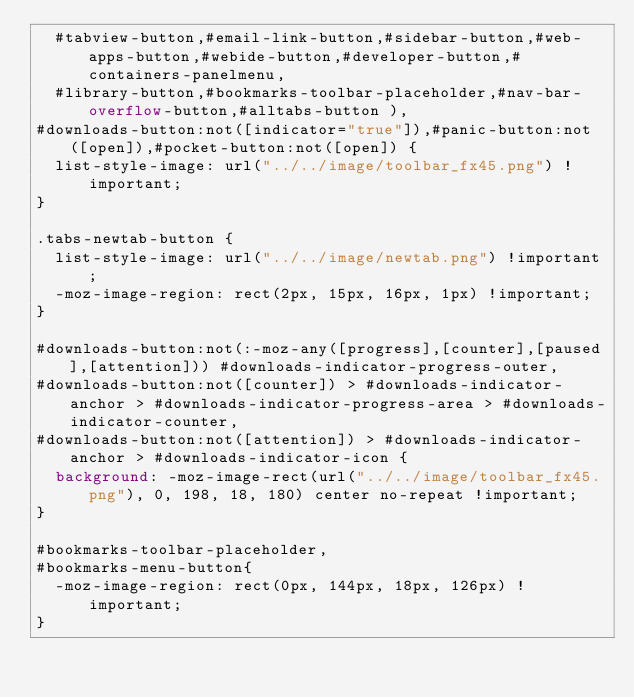<code> <loc_0><loc_0><loc_500><loc_500><_CSS_>	#tabview-button,#email-link-button,#sidebar-button,#web-apps-button,#webide-button,#developer-button,#containers-panelmenu,
	#library-button,#bookmarks-toolbar-placeholder,#nav-bar-overflow-button,#alltabs-button ),
#downloads-button:not([indicator="true"]),#panic-button:not([open]),#pocket-button:not([open]) {
  list-style-image: url("../../image/toolbar_fx45.png") !important;
}

.tabs-newtab-button {
  list-style-image: url("../../image/newtab.png") !important;
  -moz-image-region: rect(2px, 15px, 16px, 1px) !important;
}

#downloads-button:not(:-moz-any([progress],[counter],[paused],[attention])) #downloads-indicator-progress-outer,
#downloads-button:not([counter]) > #downloads-indicator-anchor > #downloads-indicator-progress-area > #downloads-indicator-counter,
#downloads-button:not([attention]) > #downloads-indicator-anchor > #downloads-indicator-icon {
  background: -moz-image-rect(url("../../image/toolbar_fx45.png"), 0, 198, 18, 180) center no-repeat !important;
}

#bookmarks-toolbar-placeholder,
#bookmarks-menu-button{
  -moz-image-region: rect(0px, 144px, 18px, 126px) !important;
}</code> 